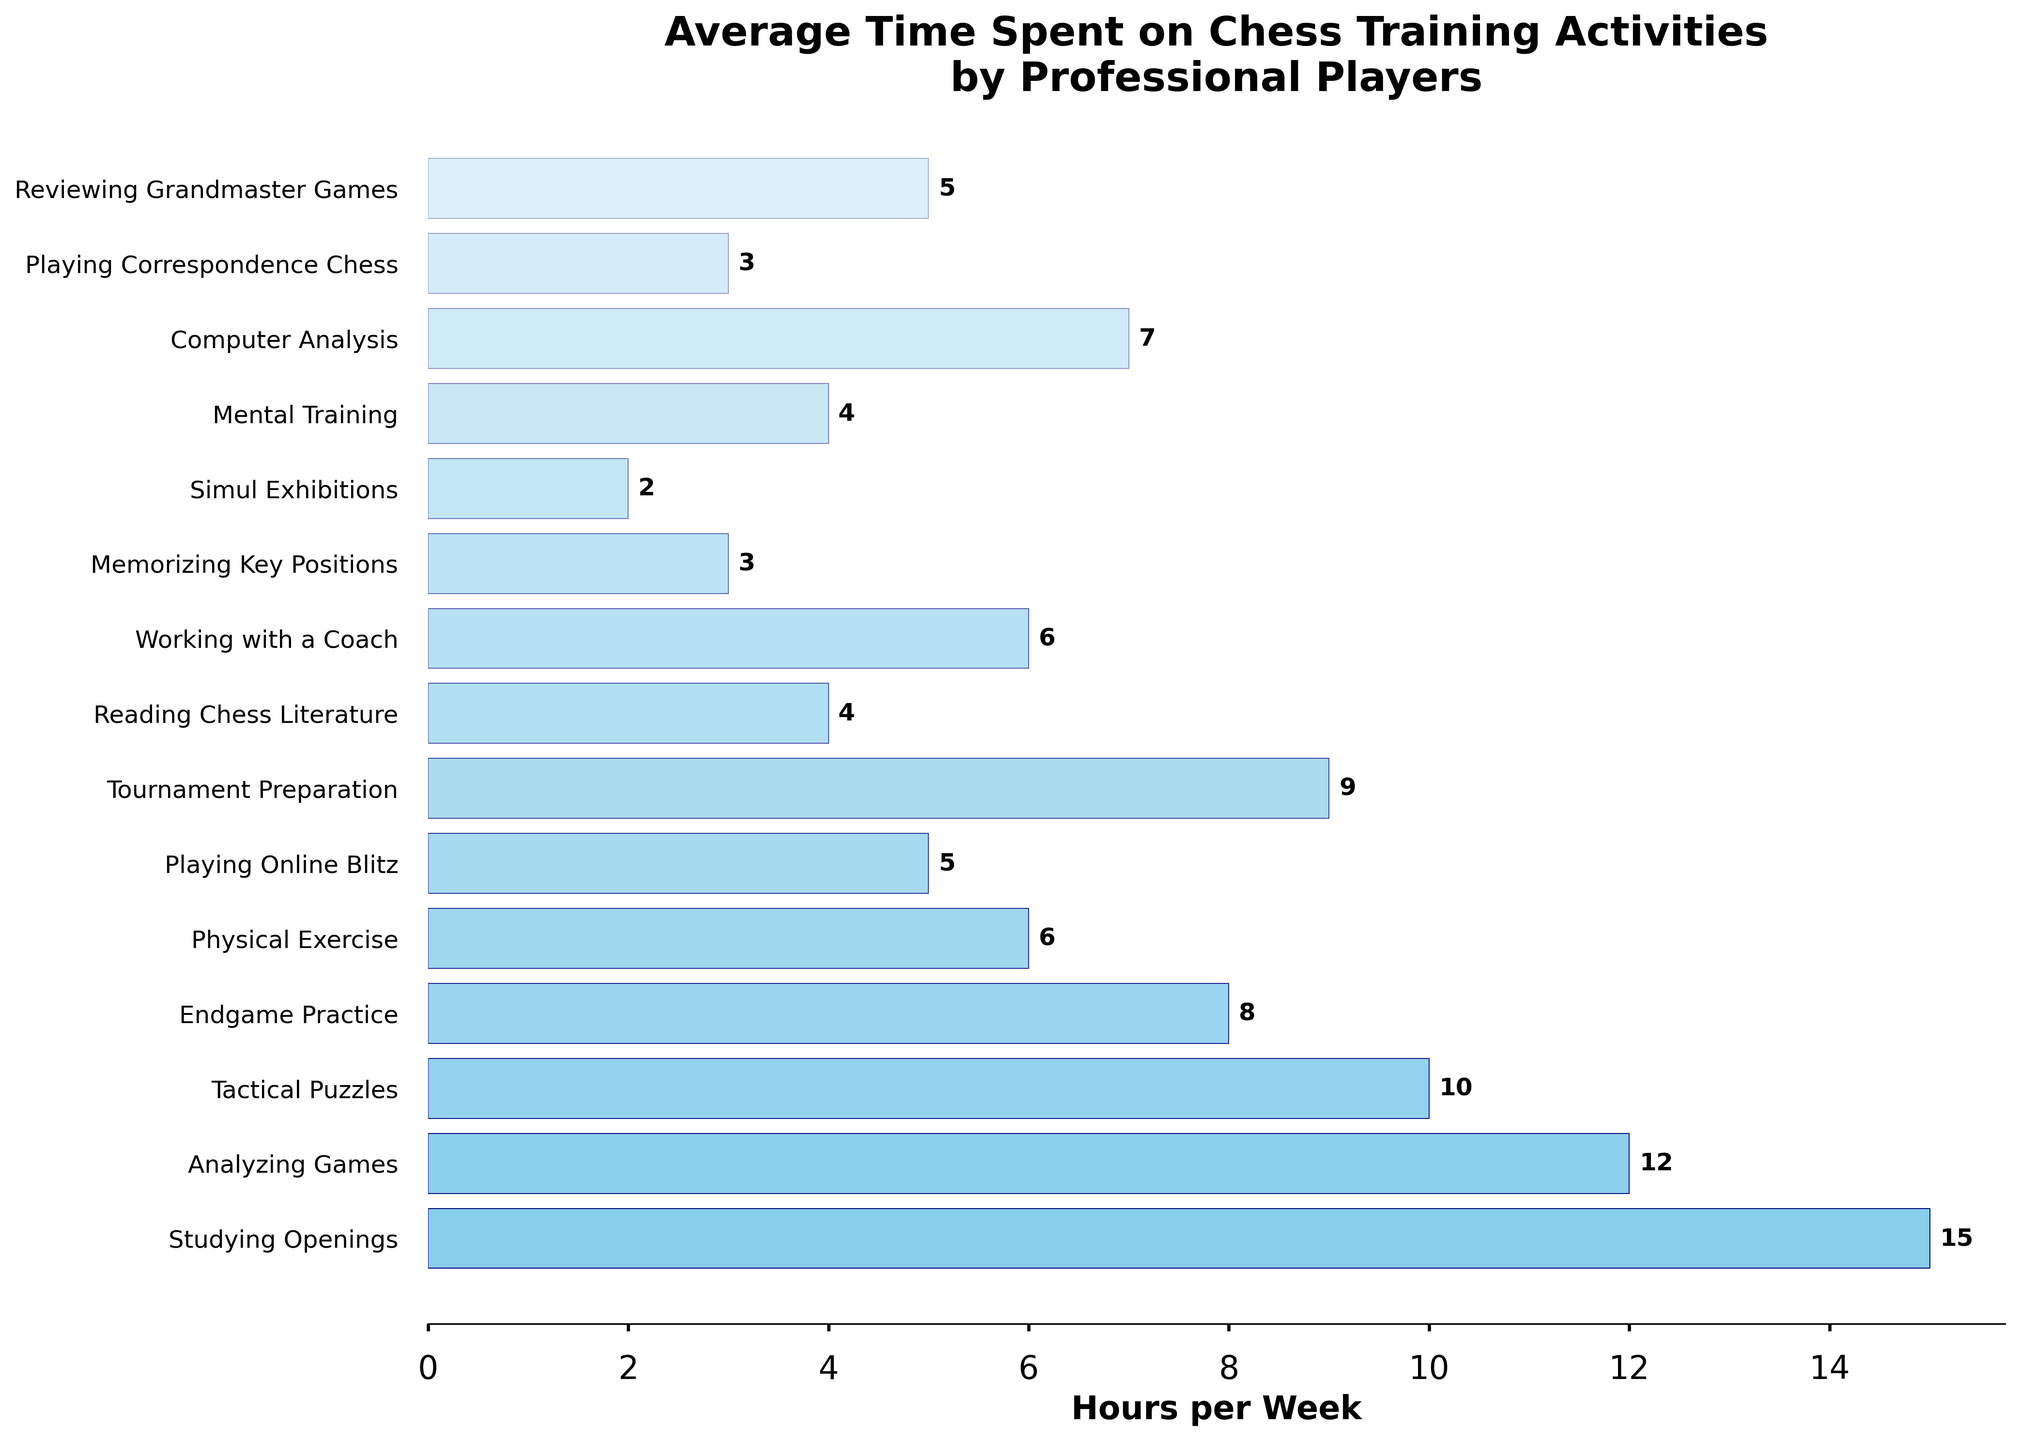What activity do professional players spend the most time on per week? The figure shows the bar length of each activity. The longest bar corresponds to "Studying Openings" which indicates the highest hours per week.
Answer: Studying Openings How many hours do professional players spend on tactical puzzles compared to analyzing games? The figure shows the hours directly. Tactical puzzles take 10 hours per week, while analyzing games takes 12 hours per week. The difference is 12 - 10 = 2 hours.
Answer: 2 hours Which activities have the same number of hours per week as physical exercise? By examining the bars, physical exercise has 6 hours per week. Both “Working with a Coach” and "Reviewing Grandmaster Games" also have 6 hours per week.
Answer: Working with a Coach, Reviewing Grandmaster Games What is the total time spent on endgame practice and tournament preparation? The figure shows the time spent on each activity. Adding the hours for endgame practice (8) and tournament preparation (9) gives 8 + 9 = 17 hours.
Answer: 17 hours Which activity has the least average time spent per week? The shortest bar represents "Simul Exhibitions" indicating the least number of hours, which is 2.
Answer: Simul Exhibitions What is the combined time spent on mental training and reading chess literature compared to studying openings? Mental training is 4 hours, reading chess literature is 4 hours. Combined is 4 + 4 = 8 hours. Studying openings is 15 hours, so the difference is 15 - 8 = 7 hours more for studying openings.
Answer: 7 hours more How does the time spent on computer analysis compare to time spent playing online blitz? The bar for computer analysis shows 7 hours, while playing online blitz is 5 hours. Hence, 7 is greater than 5 by 2 hours.
Answer: 2 hours more Is endgame practice time greater than mental training plus physical exercise time? Endgame practice is 8 hours. Mental training (4) + physical exercise (6) = 10 hours. Therefore, 8 is less than 10.
Answer: No What are the three activities that have the shortest average time per week? The shortest bars correspond to "Simul Exhibitions" (2 hours), "Memorizing Key Positions" (3 hours), and "Playing Correspondence Chess" (3 hours).
Answer: Simul Exhibitions, Memorizing Key Positions, Playing Correspondence Chess What is the median value of hours spent on all training activities? List all the hours in ascending order: (2, 3, 3, 4, 4, 5, 5, 6, 6, 7, 8, 9, 10, 12, 15). The middle value/median is the 8th value in this list, which is 6.
Answer: 6 hours 